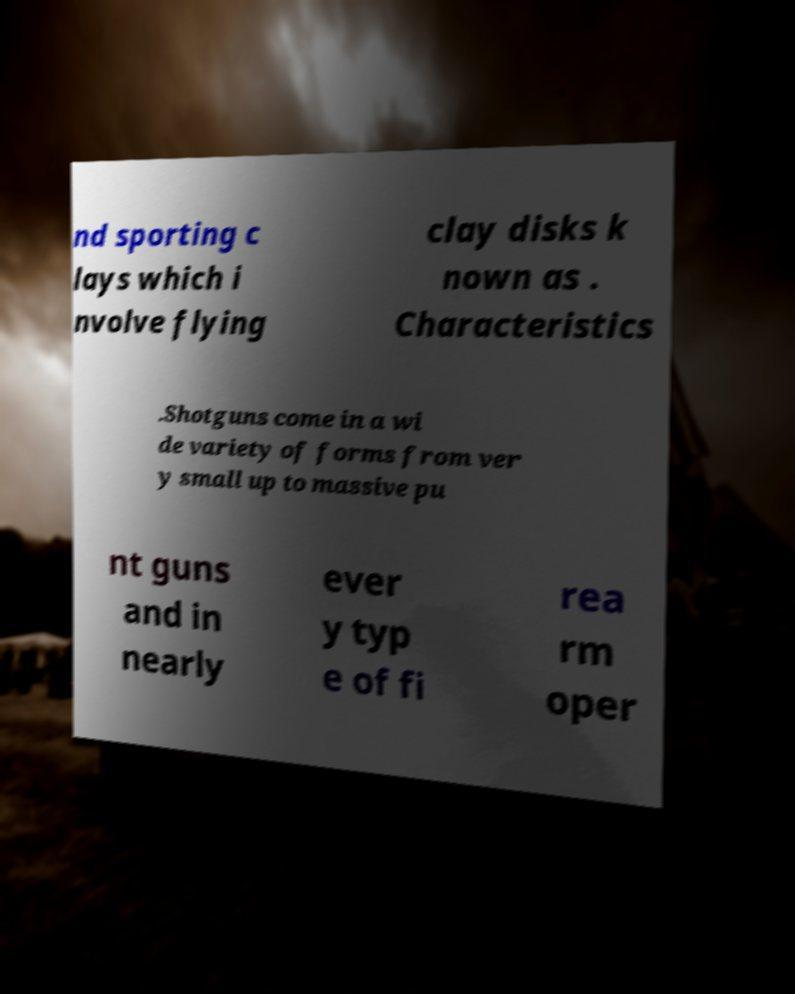Please identify and transcribe the text found in this image. nd sporting c lays which i nvolve flying clay disks k nown as . Characteristics .Shotguns come in a wi de variety of forms from ver y small up to massive pu nt guns and in nearly ever y typ e of fi rea rm oper 